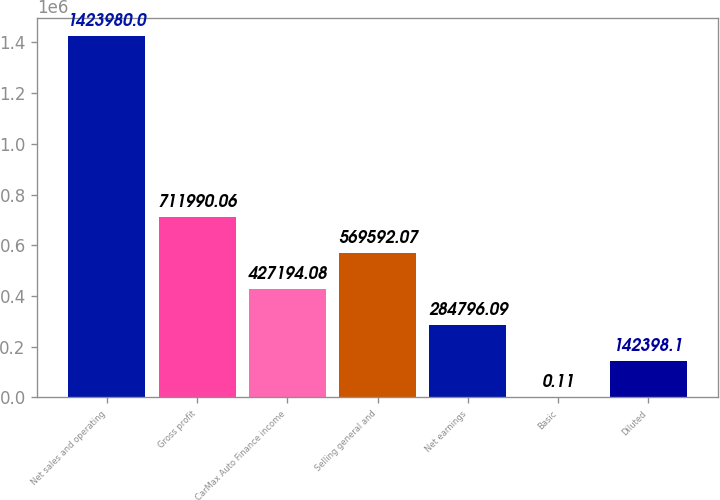Convert chart to OTSL. <chart><loc_0><loc_0><loc_500><loc_500><bar_chart><fcel>Net sales and operating<fcel>Gross profit<fcel>CarMax Auto Finance income<fcel>Selling general and<fcel>Net earnings<fcel>Basic<fcel>Diluted<nl><fcel>1.42398e+06<fcel>711990<fcel>427194<fcel>569592<fcel>284796<fcel>0.11<fcel>142398<nl></chart> 